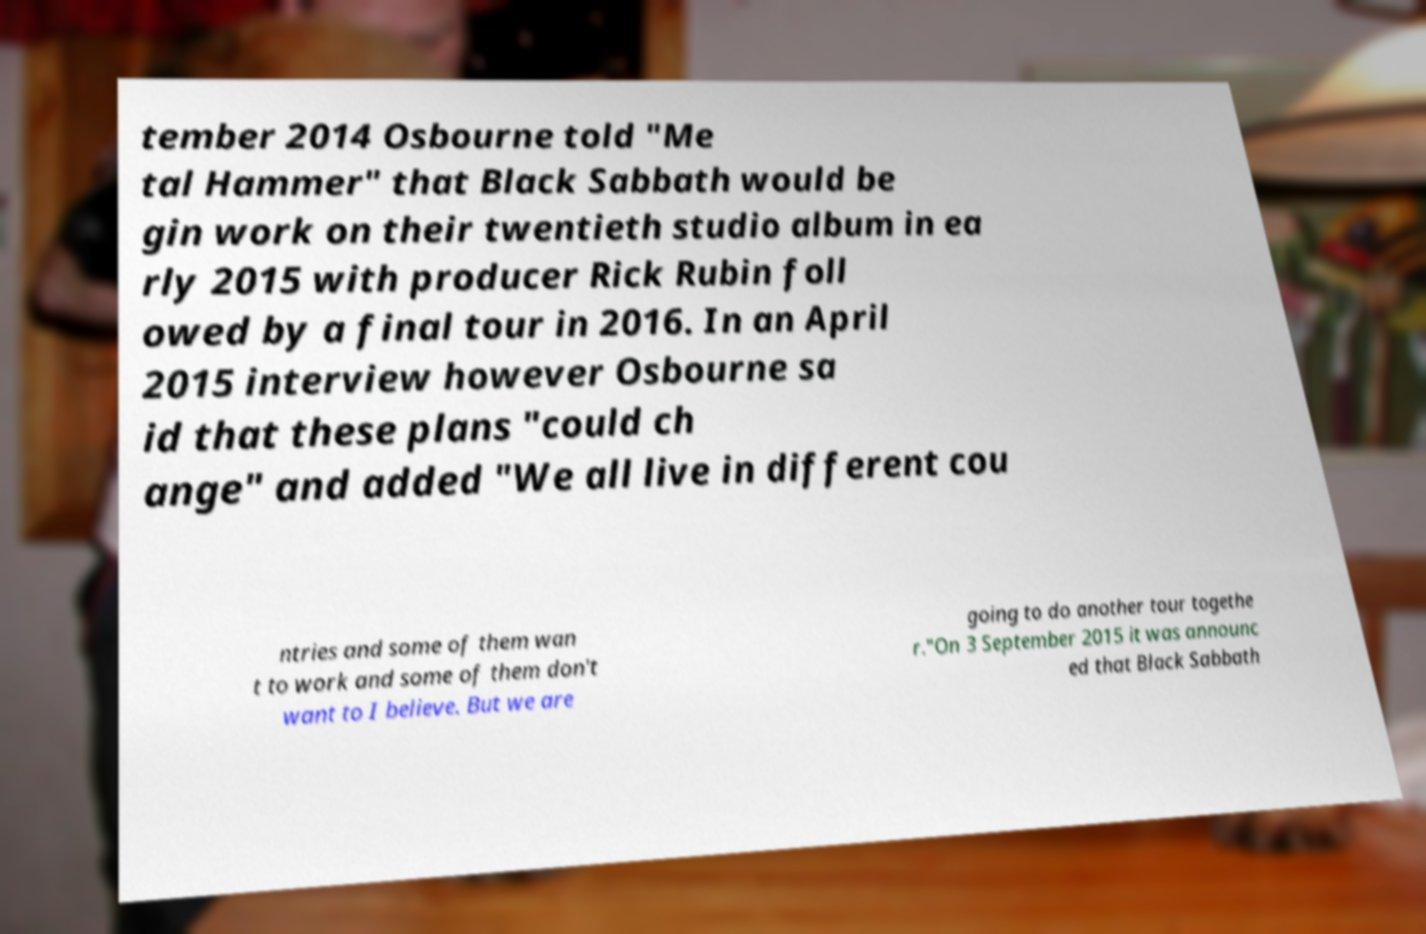Can you accurately transcribe the text from the provided image for me? tember 2014 Osbourne told "Me tal Hammer" that Black Sabbath would be gin work on their twentieth studio album in ea rly 2015 with producer Rick Rubin foll owed by a final tour in 2016. In an April 2015 interview however Osbourne sa id that these plans "could ch ange" and added "We all live in different cou ntries and some of them wan t to work and some of them don't want to I believe. But we are going to do another tour togethe r."On 3 September 2015 it was announc ed that Black Sabbath 